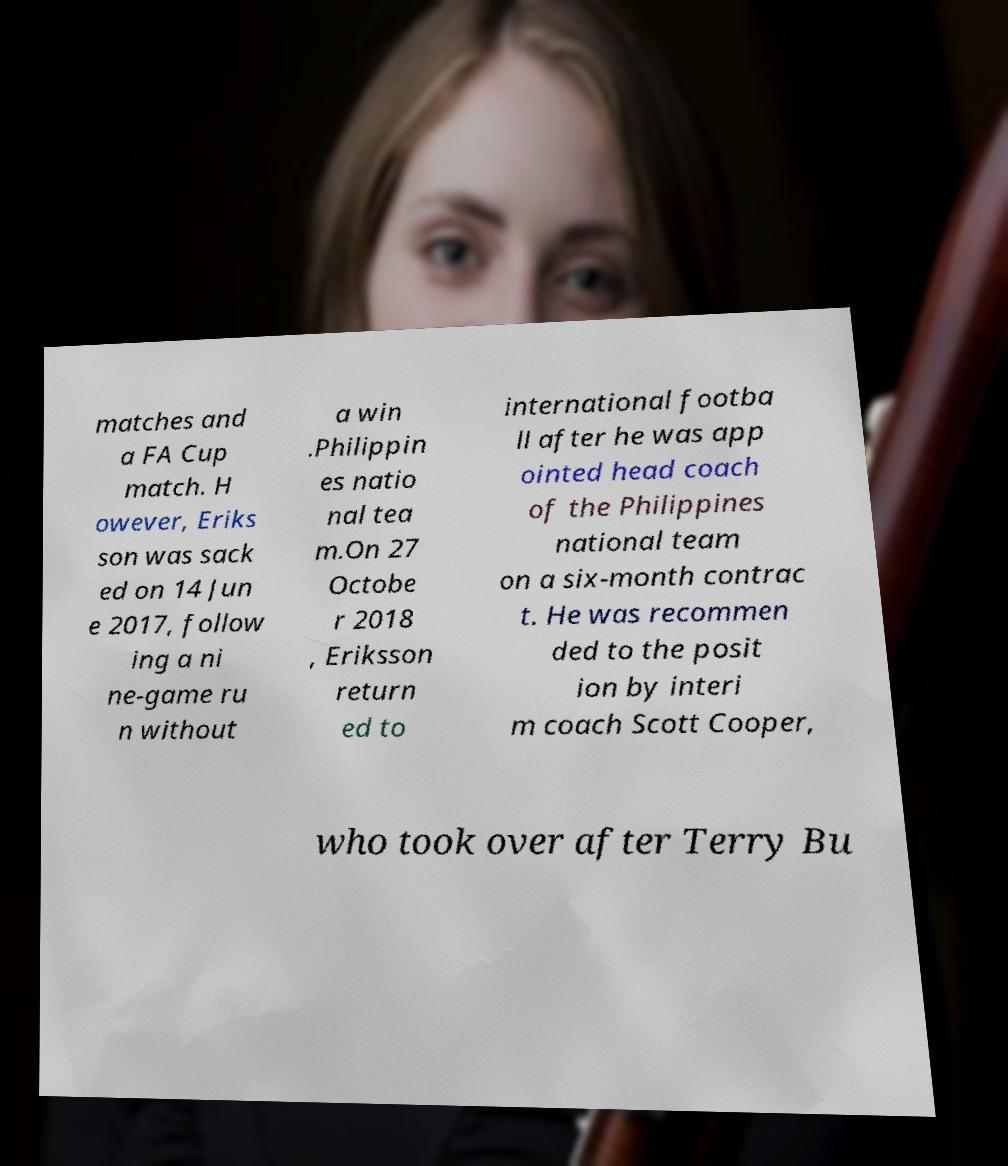Can you accurately transcribe the text from the provided image for me? matches and a FA Cup match. H owever, Eriks son was sack ed on 14 Jun e 2017, follow ing a ni ne-game ru n without a win .Philippin es natio nal tea m.On 27 Octobe r 2018 , Eriksson return ed to international footba ll after he was app ointed head coach of the Philippines national team on a six-month contrac t. He was recommen ded to the posit ion by interi m coach Scott Cooper, who took over after Terry Bu 